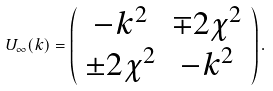Convert formula to latex. <formula><loc_0><loc_0><loc_500><loc_500>U _ { \infty } ( k ) = \left ( \begin{array} { c c } - k ^ { 2 } & \mp 2 \chi ^ { 2 } \\ \pm 2 \chi ^ { 2 } & - k ^ { 2 } \end{array} \right ) .</formula> 